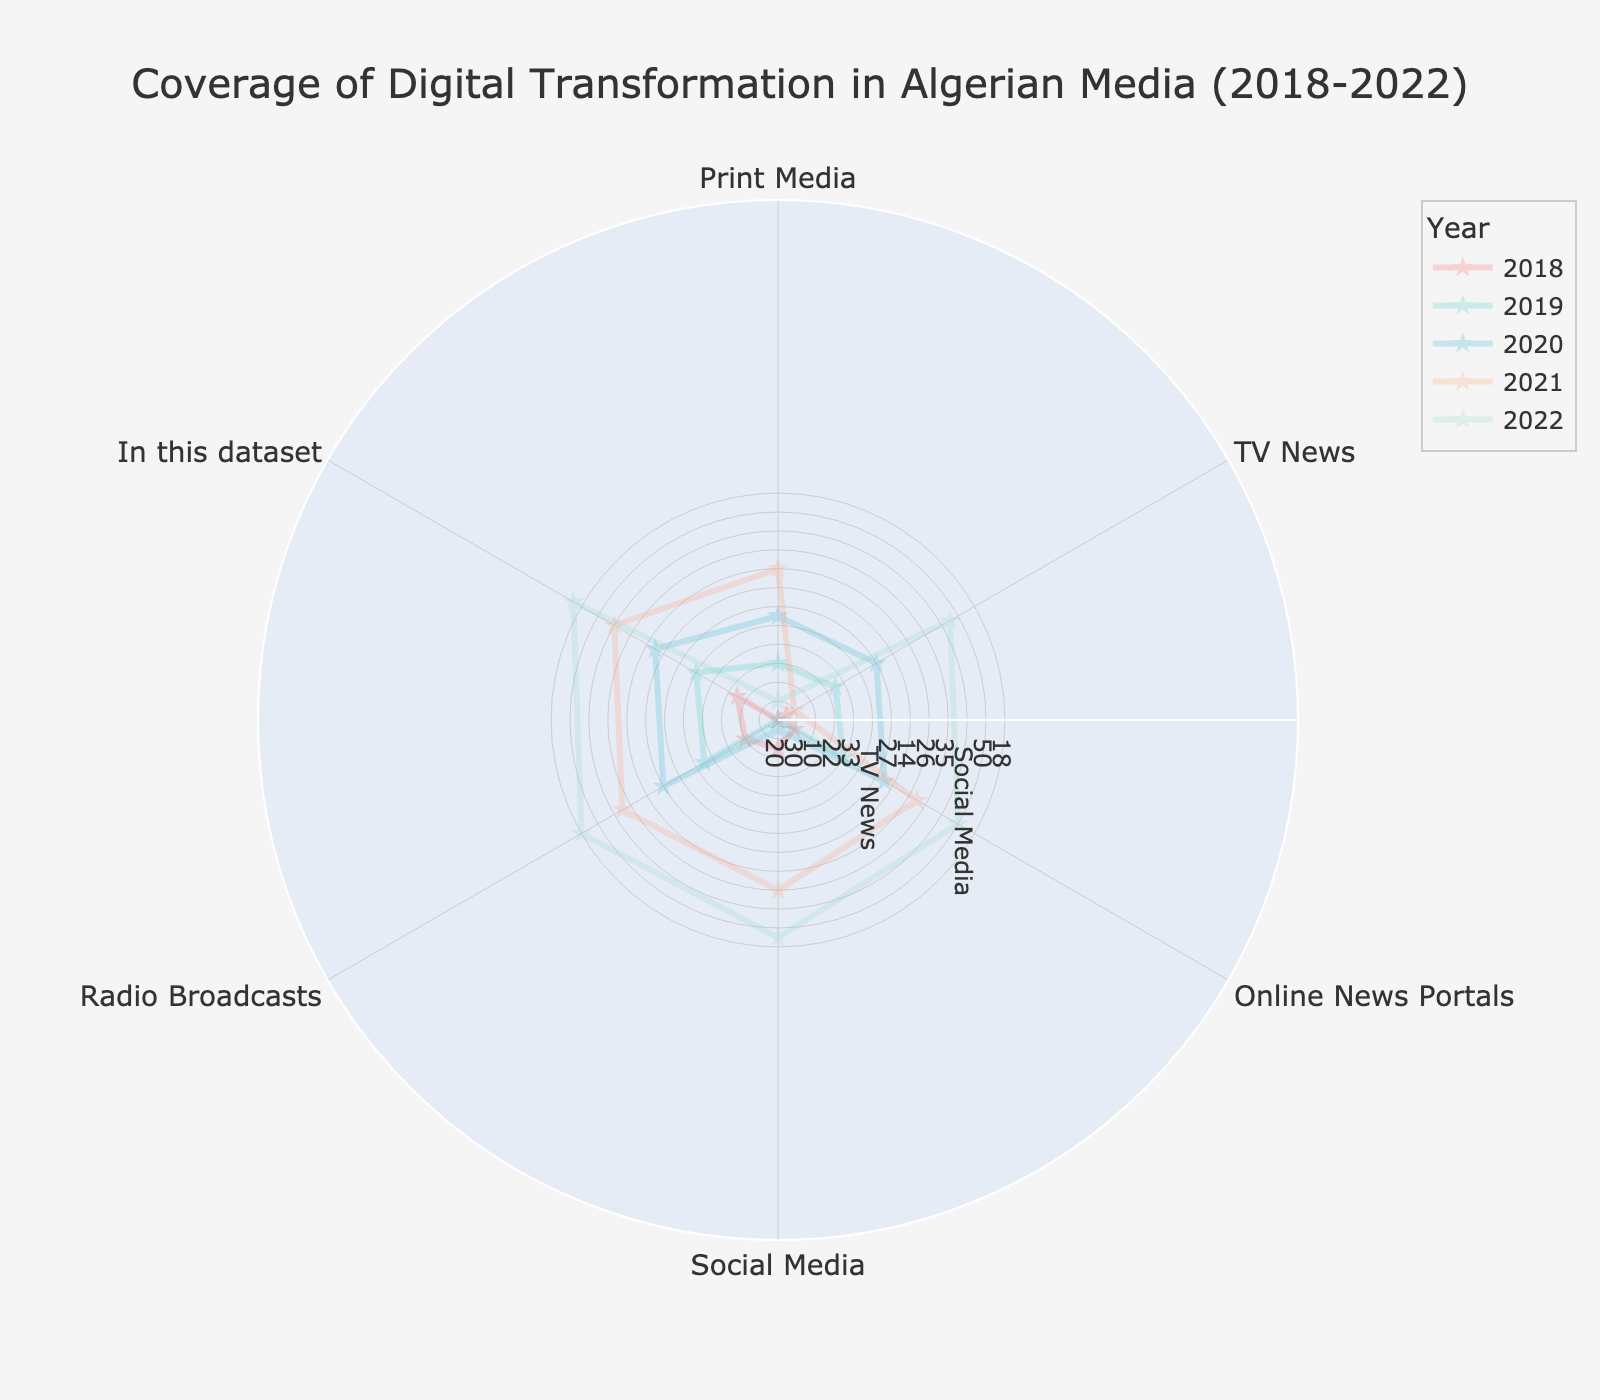What are the categories covered in the radar chart? The radar chart's visual structure displays different media categories arranged around a circle. This would list the categories as "Print Media," "TV News," "Online News Portals," "Social Media," and "Radio Broadcasts."
Answer: Print Media, TV News, Online News Portals, Social Media, Radio Broadcasts Which category saw the highest coverage in 2022? Observing the outermost edge of the radar chart for the year 2022 trace, the category with the highest value is identified.
Answer: Online News Portals What is the title of the radar chart? The title is typically located at the top center of the radar chart and provides the main theme of the chart.
Answer: Coverage of Digital Transformation in Algerian Media (2018-2022) How much did the coverage of "Radio Broadcasts" change from 2018 to 2022? Comparing the 2018 and 2022 points on the "Radio Broadcasts" axis reveals the starting and ending values. Subtract the 2018 value from the 2022 value.
Answer: 8 Which year had the least coverage in "Social Media"? Identify the smallest point on the "Social Media" axis corresponding to the five years shown by different traces.
Answer: 2018 What is the average coverage of "Print Media" from 2018 to 2022? Sum the coverage values of "Print Media" for each year from 2018 to 2022 and divide by the number of years, which is 5.
Answer: 24.4 Between which two consecutive years did "TV News" see the largest increase in coverage? Calculate the differences in coverage for "TV News" between each consecutive year, and determine the pair of years with the greatest difference.
Answer: 2021 and 2022 Which category saw the most significant increase from 2018 to 2022? Calculate the difference in coverage for each category between 2018 and 2022, and identify the category with the largest increase.
Answer: Social Media How did the coverage for "Online News Portals" evolve over the five years? Observe the trajectory of "Online News Portals" values across the years, noting any trends.p
Answer: Consistently increased In which year did "Print Media" and "Radio Broadcasts" have the closest coverage values? Calculate the absolute differences between "Print Media" and "Radio Broadcasts" values for each year, and identify the year with the smallest difference.
Answer: 2021 